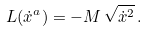<formula> <loc_0><loc_0><loc_500><loc_500>L ( \dot { x } ^ { a } ) = - M \, \sqrt { \dot { x } ^ { 2 } } \, .</formula> 